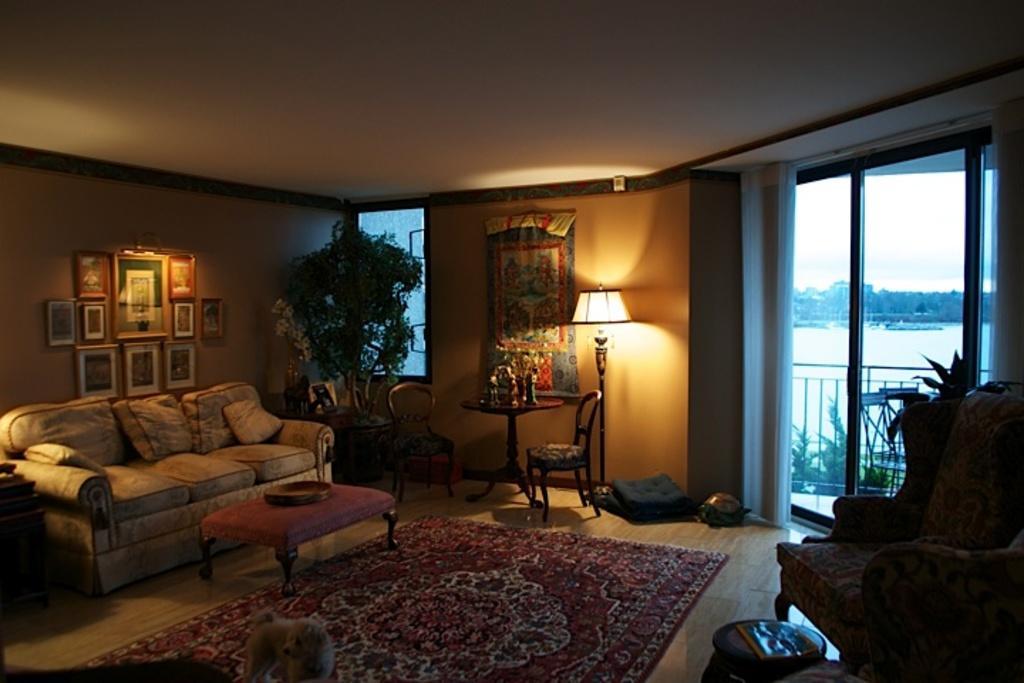How would you summarize this image in a sentence or two? In this image, we can see right side, there is a chair. Left side, there is a couch. So many photo frames are on the wall. There is a plant at the middle of the image. Chairs, table. Few items are placed on it. Here there is cloth, lamp and cushions at the bottom. In the bottom, floor mat, table and dog here. On right side background, we can see glass window, plants, fencing,water and some buildings. 